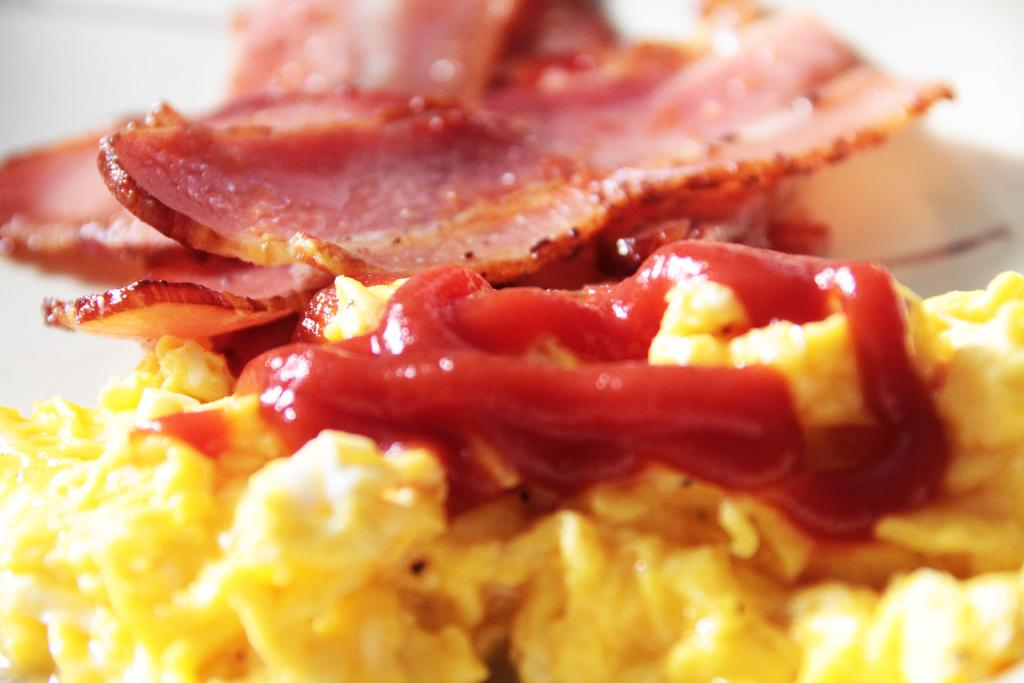What can be seen in the image? There is a food item in the image. Can you see any monkeys interacting with the food item in the image? There is no mention of monkeys or any interaction with the food item in the image. 